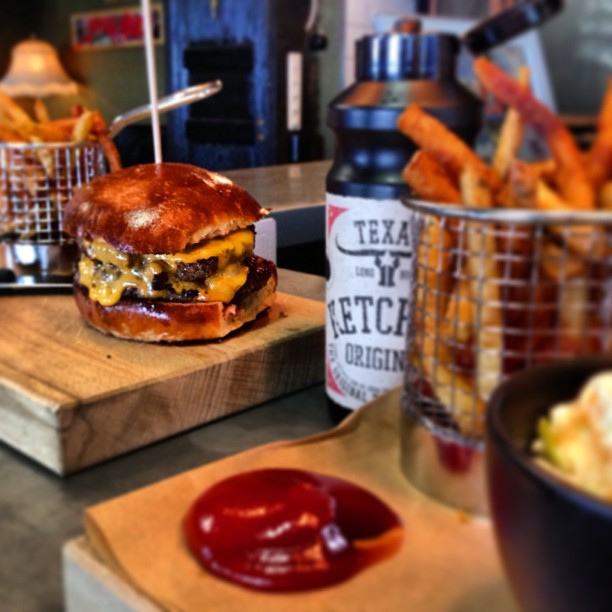Please transcribe the text information in this image. TEXA KETCH ORIGIN 